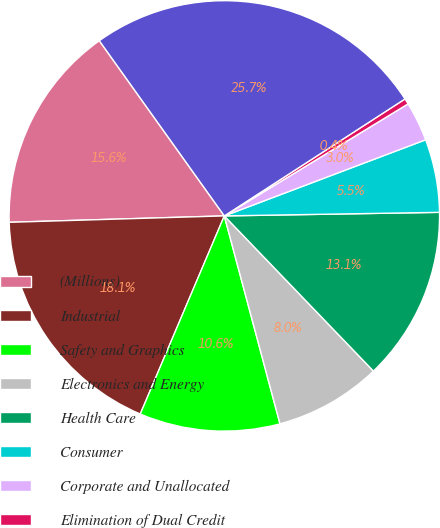Convert chart to OTSL. <chart><loc_0><loc_0><loc_500><loc_500><pie_chart><fcel>(Millions)<fcel>Industrial<fcel>Safety and Graphics<fcel>Electronics and Energy<fcel>Health Care<fcel>Consumer<fcel>Corporate and Unallocated<fcel>Elimination of Dual Credit<fcel>Total Company<nl><fcel>15.61%<fcel>18.14%<fcel>10.55%<fcel>8.02%<fcel>13.08%<fcel>5.49%<fcel>2.96%<fcel>0.43%<fcel>25.72%<nl></chart> 